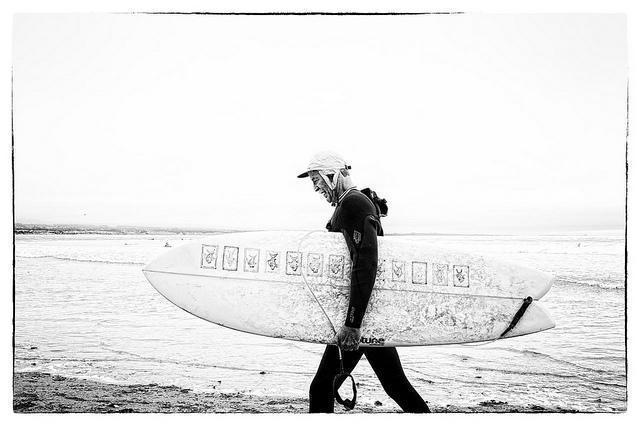How many zebras are facing right in the picture?
Give a very brief answer. 0. 